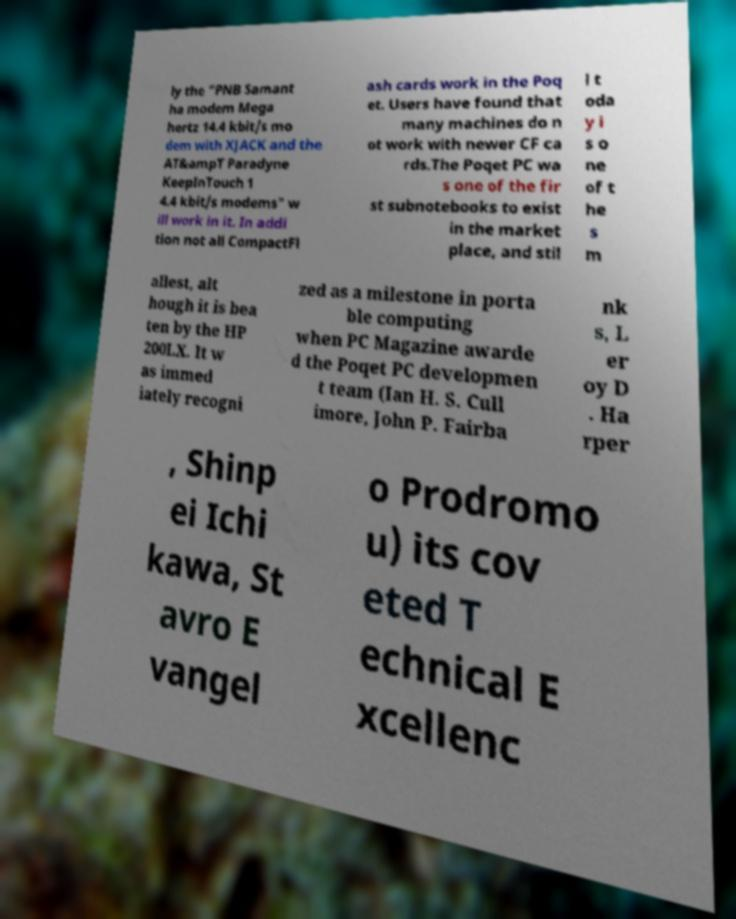There's text embedded in this image that I need extracted. Can you transcribe it verbatim? ly the "PNB Samant ha modem Mega hertz 14.4 kbit/s mo dem with XJACK and the AT&ampT Paradyne KeepInTouch 1 4.4 kbit/s modems" w ill work in it. In addi tion not all CompactFl ash cards work in the Poq et. Users have found that many machines do n ot work with newer CF ca rds.The Poqet PC wa s one of the fir st subnotebooks to exist in the market place, and stil l t oda y i s o ne of t he s m allest, alt hough it is bea ten by the HP 200LX. It w as immed iately recogni zed as a milestone in porta ble computing when PC Magazine awarde d the Poqet PC developmen t team (Ian H. S. Cull imore, John P. Fairba nk s, L er oy D . Ha rper , Shinp ei Ichi kawa, St avro E vangel o Prodromo u) its cov eted T echnical E xcellenc 